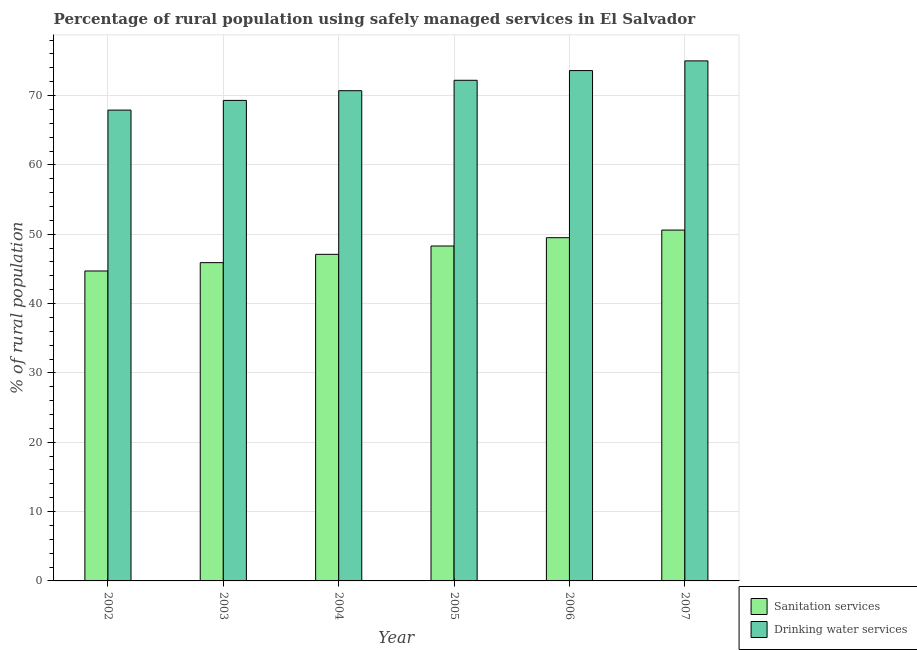How many different coloured bars are there?
Ensure brevity in your answer.  2. What is the label of the 4th group of bars from the left?
Give a very brief answer. 2005. What is the percentage of rural population who used sanitation services in 2003?
Your answer should be compact. 45.9. Across all years, what is the maximum percentage of rural population who used drinking water services?
Offer a very short reply. 75. Across all years, what is the minimum percentage of rural population who used drinking water services?
Give a very brief answer. 67.9. In which year was the percentage of rural population who used sanitation services maximum?
Offer a very short reply. 2007. In which year was the percentage of rural population who used drinking water services minimum?
Provide a short and direct response. 2002. What is the total percentage of rural population who used drinking water services in the graph?
Make the answer very short. 428.7. What is the difference between the percentage of rural population who used drinking water services in 2003 and that in 2006?
Provide a succinct answer. -4.3. What is the difference between the percentage of rural population who used sanitation services in 2003 and the percentage of rural population who used drinking water services in 2006?
Your answer should be compact. -3.6. What is the average percentage of rural population who used sanitation services per year?
Give a very brief answer. 47.68. In the year 2002, what is the difference between the percentage of rural population who used drinking water services and percentage of rural population who used sanitation services?
Keep it short and to the point. 0. What is the ratio of the percentage of rural population who used drinking water services in 2002 to that in 2006?
Your answer should be very brief. 0.92. What is the difference between the highest and the second highest percentage of rural population who used sanitation services?
Ensure brevity in your answer.  1.1. What is the difference between the highest and the lowest percentage of rural population who used sanitation services?
Provide a succinct answer. 5.9. In how many years, is the percentage of rural population who used drinking water services greater than the average percentage of rural population who used drinking water services taken over all years?
Your response must be concise. 3. What does the 2nd bar from the left in 2003 represents?
Give a very brief answer. Drinking water services. What does the 2nd bar from the right in 2002 represents?
Give a very brief answer. Sanitation services. What is the difference between two consecutive major ticks on the Y-axis?
Make the answer very short. 10. Does the graph contain any zero values?
Offer a terse response. No. Does the graph contain grids?
Your answer should be compact. Yes. How many legend labels are there?
Your response must be concise. 2. How are the legend labels stacked?
Offer a terse response. Vertical. What is the title of the graph?
Ensure brevity in your answer.  Percentage of rural population using safely managed services in El Salvador. What is the label or title of the X-axis?
Provide a succinct answer. Year. What is the label or title of the Y-axis?
Your answer should be compact. % of rural population. What is the % of rural population in Sanitation services in 2002?
Offer a terse response. 44.7. What is the % of rural population in Drinking water services in 2002?
Keep it short and to the point. 67.9. What is the % of rural population of Sanitation services in 2003?
Offer a very short reply. 45.9. What is the % of rural population of Drinking water services in 2003?
Your answer should be compact. 69.3. What is the % of rural population in Sanitation services in 2004?
Your answer should be compact. 47.1. What is the % of rural population in Drinking water services in 2004?
Your answer should be compact. 70.7. What is the % of rural population in Sanitation services in 2005?
Make the answer very short. 48.3. What is the % of rural population of Drinking water services in 2005?
Make the answer very short. 72.2. What is the % of rural population in Sanitation services in 2006?
Provide a short and direct response. 49.5. What is the % of rural population of Drinking water services in 2006?
Your response must be concise. 73.6. What is the % of rural population in Sanitation services in 2007?
Ensure brevity in your answer.  50.6. Across all years, what is the maximum % of rural population in Sanitation services?
Provide a short and direct response. 50.6. Across all years, what is the minimum % of rural population of Sanitation services?
Provide a short and direct response. 44.7. Across all years, what is the minimum % of rural population of Drinking water services?
Offer a very short reply. 67.9. What is the total % of rural population in Sanitation services in the graph?
Your response must be concise. 286.1. What is the total % of rural population of Drinking water services in the graph?
Provide a succinct answer. 428.7. What is the difference between the % of rural population in Sanitation services in 2002 and that in 2003?
Make the answer very short. -1.2. What is the difference between the % of rural population in Drinking water services in 2002 and that in 2003?
Your answer should be very brief. -1.4. What is the difference between the % of rural population of Sanitation services in 2002 and that in 2004?
Give a very brief answer. -2.4. What is the difference between the % of rural population in Drinking water services in 2002 and that in 2004?
Make the answer very short. -2.8. What is the difference between the % of rural population of Sanitation services in 2002 and that in 2005?
Offer a terse response. -3.6. What is the difference between the % of rural population in Sanitation services in 2002 and that in 2006?
Offer a very short reply. -4.8. What is the difference between the % of rural population in Drinking water services in 2002 and that in 2006?
Your response must be concise. -5.7. What is the difference between the % of rural population of Drinking water services in 2002 and that in 2007?
Your response must be concise. -7.1. What is the difference between the % of rural population of Sanitation services in 2003 and that in 2004?
Provide a succinct answer. -1.2. What is the difference between the % of rural population in Sanitation services in 2003 and that in 2005?
Offer a very short reply. -2.4. What is the difference between the % of rural population of Sanitation services in 2003 and that in 2006?
Your answer should be very brief. -3.6. What is the difference between the % of rural population of Sanitation services in 2003 and that in 2007?
Ensure brevity in your answer.  -4.7. What is the difference between the % of rural population in Drinking water services in 2003 and that in 2007?
Offer a terse response. -5.7. What is the difference between the % of rural population of Drinking water services in 2004 and that in 2005?
Offer a very short reply. -1.5. What is the difference between the % of rural population in Sanitation services in 2004 and that in 2006?
Your response must be concise. -2.4. What is the difference between the % of rural population in Sanitation services in 2004 and that in 2007?
Keep it short and to the point. -3.5. What is the difference between the % of rural population of Drinking water services in 2004 and that in 2007?
Offer a very short reply. -4.3. What is the difference between the % of rural population of Drinking water services in 2006 and that in 2007?
Give a very brief answer. -1.4. What is the difference between the % of rural population of Sanitation services in 2002 and the % of rural population of Drinking water services in 2003?
Ensure brevity in your answer.  -24.6. What is the difference between the % of rural population in Sanitation services in 2002 and the % of rural population in Drinking water services in 2005?
Offer a very short reply. -27.5. What is the difference between the % of rural population in Sanitation services in 2002 and the % of rural population in Drinking water services in 2006?
Your response must be concise. -28.9. What is the difference between the % of rural population of Sanitation services in 2002 and the % of rural population of Drinking water services in 2007?
Offer a very short reply. -30.3. What is the difference between the % of rural population of Sanitation services in 2003 and the % of rural population of Drinking water services in 2004?
Offer a very short reply. -24.8. What is the difference between the % of rural population in Sanitation services in 2003 and the % of rural population in Drinking water services in 2005?
Your answer should be compact. -26.3. What is the difference between the % of rural population in Sanitation services in 2003 and the % of rural population in Drinking water services in 2006?
Your answer should be very brief. -27.7. What is the difference between the % of rural population in Sanitation services in 2003 and the % of rural population in Drinking water services in 2007?
Offer a very short reply. -29.1. What is the difference between the % of rural population in Sanitation services in 2004 and the % of rural population in Drinking water services in 2005?
Your answer should be very brief. -25.1. What is the difference between the % of rural population in Sanitation services in 2004 and the % of rural population in Drinking water services in 2006?
Make the answer very short. -26.5. What is the difference between the % of rural population of Sanitation services in 2004 and the % of rural population of Drinking water services in 2007?
Provide a short and direct response. -27.9. What is the difference between the % of rural population in Sanitation services in 2005 and the % of rural population in Drinking water services in 2006?
Give a very brief answer. -25.3. What is the difference between the % of rural population of Sanitation services in 2005 and the % of rural population of Drinking water services in 2007?
Provide a succinct answer. -26.7. What is the difference between the % of rural population of Sanitation services in 2006 and the % of rural population of Drinking water services in 2007?
Provide a short and direct response. -25.5. What is the average % of rural population of Sanitation services per year?
Provide a succinct answer. 47.68. What is the average % of rural population in Drinking water services per year?
Provide a short and direct response. 71.45. In the year 2002, what is the difference between the % of rural population of Sanitation services and % of rural population of Drinking water services?
Provide a succinct answer. -23.2. In the year 2003, what is the difference between the % of rural population in Sanitation services and % of rural population in Drinking water services?
Give a very brief answer. -23.4. In the year 2004, what is the difference between the % of rural population in Sanitation services and % of rural population in Drinking water services?
Offer a terse response. -23.6. In the year 2005, what is the difference between the % of rural population of Sanitation services and % of rural population of Drinking water services?
Give a very brief answer. -23.9. In the year 2006, what is the difference between the % of rural population of Sanitation services and % of rural population of Drinking water services?
Offer a terse response. -24.1. In the year 2007, what is the difference between the % of rural population of Sanitation services and % of rural population of Drinking water services?
Offer a terse response. -24.4. What is the ratio of the % of rural population in Sanitation services in 2002 to that in 2003?
Offer a terse response. 0.97. What is the ratio of the % of rural population in Drinking water services in 2002 to that in 2003?
Ensure brevity in your answer.  0.98. What is the ratio of the % of rural population in Sanitation services in 2002 to that in 2004?
Offer a terse response. 0.95. What is the ratio of the % of rural population in Drinking water services in 2002 to that in 2004?
Provide a succinct answer. 0.96. What is the ratio of the % of rural population in Sanitation services in 2002 to that in 2005?
Offer a terse response. 0.93. What is the ratio of the % of rural population of Drinking water services in 2002 to that in 2005?
Ensure brevity in your answer.  0.94. What is the ratio of the % of rural population in Sanitation services in 2002 to that in 2006?
Ensure brevity in your answer.  0.9. What is the ratio of the % of rural population of Drinking water services in 2002 to that in 2006?
Give a very brief answer. 0.92. What is the ratio of the % of rural population of Sanitation services in 2002 to that in 2007?
Offer a terse response. 0.88. What is the ratio of the % of rural population of Drinking water services in 2002 to that in 2007?
Your response must be concise. 0.91. What is the ratio of the % of rural population in Sanitation services in 2003 to that in 2004?
Provide a short and direct response. 0.97. What is the ratio of the % of rural population of Drinking water services in 2003 to that in 2004?
Provide a short and direct response. 0.98. What is the ratio of the % of rural population of Sanitation services in 2003 to that in 2005?
Offer a very short reply. 0.95. What is the ratio of the % of rural population of Drinking water services in 2003 to that in 2005?
Offer a terse response. 0.96. What is the ratio of the % of rural population of Sanitation services in 2003 to that in 2006?
Offer a terse response. 0.93. What is the ratio of the % of rural population of Drinking water services in 2003 to that in 2006?
Your answer should be compact. 0.94. What is the ratio of the % of rural population of Sanitation services in 2003 to that in 2007?
Provide a succinct answer. 0.91. What is the ratio of the % of rural population in Drinking water services in 2003 to that in 2007?
Your response must be concise. 0.92. What is the ratio of the % of rural population of Sanitation services in 2004 to that in 2005?
Your response must be concise. 0.98. What is the ratio of the % of rural population of Drinking water services in 2004 to that in 2005?
Provide a succinct answer. 0.98. What is the ratio of the % of rural population in Sanitation services in 2004 to that in 2006?
Your response must be concise. 0.95. What is the ratio of the % of rural population in Drinking water services in 2004 to that in 2006?
Ensure brevity in your answer.  0.96. What is the ratio of the % of rural population of Sanitation services in 2004 to that in 2007?
Offer a terse response. 0.93. What is the ratio of the % of rural population of Drinking water services in 2004 to that in 2007?
Give a very brief answer. 0.94. What is the ratio of the % of rural population of Sanitation services in 2005 to that in 2006?
Offer a terse response. 0.98. What is the ratio of the % of rural population of Drinking water services in 2005 to that in 2006?
Keep it short and to the point. 0.98. What is the ratio of the % of rural population in Sanitation services in 2005 to that in 2007?
Your answer should be very brief. 0.95. What is the ratio of the % of rural population in Drinking water services in 2005 to that in 2007?
Your response must be concise. 0.96. What is the ratio of the % of rural population in Sanitation services in 2006 to that in 2007?
Offer a very short reply. 0.98. What is the ratio of the % of rural population in Drinking water services in 2006 to that in 2007?
Offer a very short reply. 0.98. What is the difference between the highest and the second highest % of rural population of Drinking water services?
Offer a very short reply. 1.4. What is the difference between the highest and the lowest % of rural population of Sanitation services?
Keep it short and to the point. 5.9. 